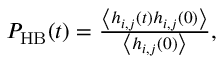Convert formula to latex. <formula><loc_0><loc_0><loc_500><loc_500>\begin{array} { r } { P _ { H B } ( t ) = \frac { \left \langle h _ { i , j } ( t ) h _ { i , j } ( 0 ) \right \rangle } { \left \langle h _ { i , j } ( 0 ) \right \rangle } , } \end{array}</formula> 